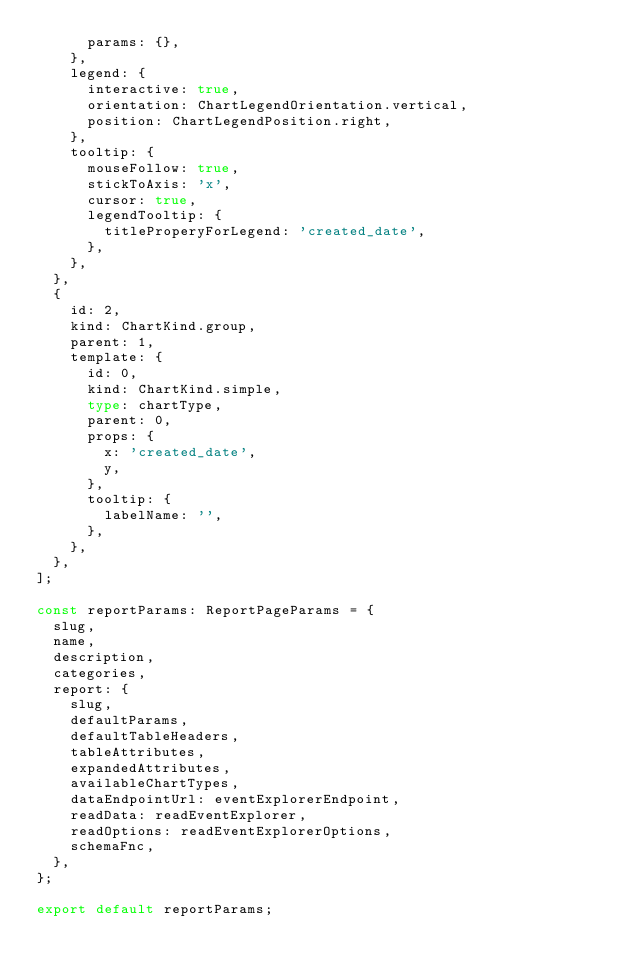<code> <loc_0><loc_0><loc_500><loc_500><_TypeScript_>      params: {},
    },
    legend: {
      interactive: true,
      orientation: ChartLegendOrientation.vertical,
      position: ChartLegendPosition.right,
    },
    tooltip: {
      mouseFollow: true,
      stickToAxis: 'x',
      cursor: true,
      legendTooltip: {
        titleProperyForLegend: 'created_date',
      },
    },
  },
  {
    id: 2,
    kind: ChartKind.group,
    parent: 1,
    template: {
      id: 0,
      kind: ChartKind.simple,
      type: chartType,
      parent: 0,
      props: {
        x: 'created_date',
        y,
      },
      tooltip: {
        labelName: '',
      },
    },
  },
];

const reportParams: ReportPageParams = {
  slug,
  name,
  description,
  categories,
  report: {
    slug,
    defaultParams,
    defaultTableHeaders,
    tableAttributes,
    expandedAttributes,
    availableChartTypes,
    dataEndpointUrl: eventExplorerEndpoint,
    readData: readEventExplorer,
    readOptions: readEventExplorerOptions,
    schemaFnc,
  },
};

export default reportParams;
</code> 